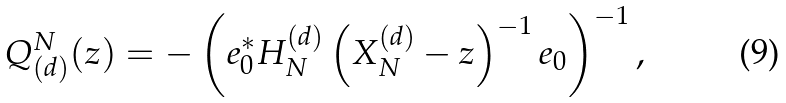<formula> <loc_0><loc_0><loc_500><loc_500>Q _ { ( d ) } ^ { N } ( z ) = - \left ( e _ { 0 } ^ { * } H _ { N } ^ { ( d ) } \left ( X ^ { ( d ) } _ { N } - z \right ) ^ { - 1 } e _ { 0 } \right ) ^ { - 1 } ,</formula> 